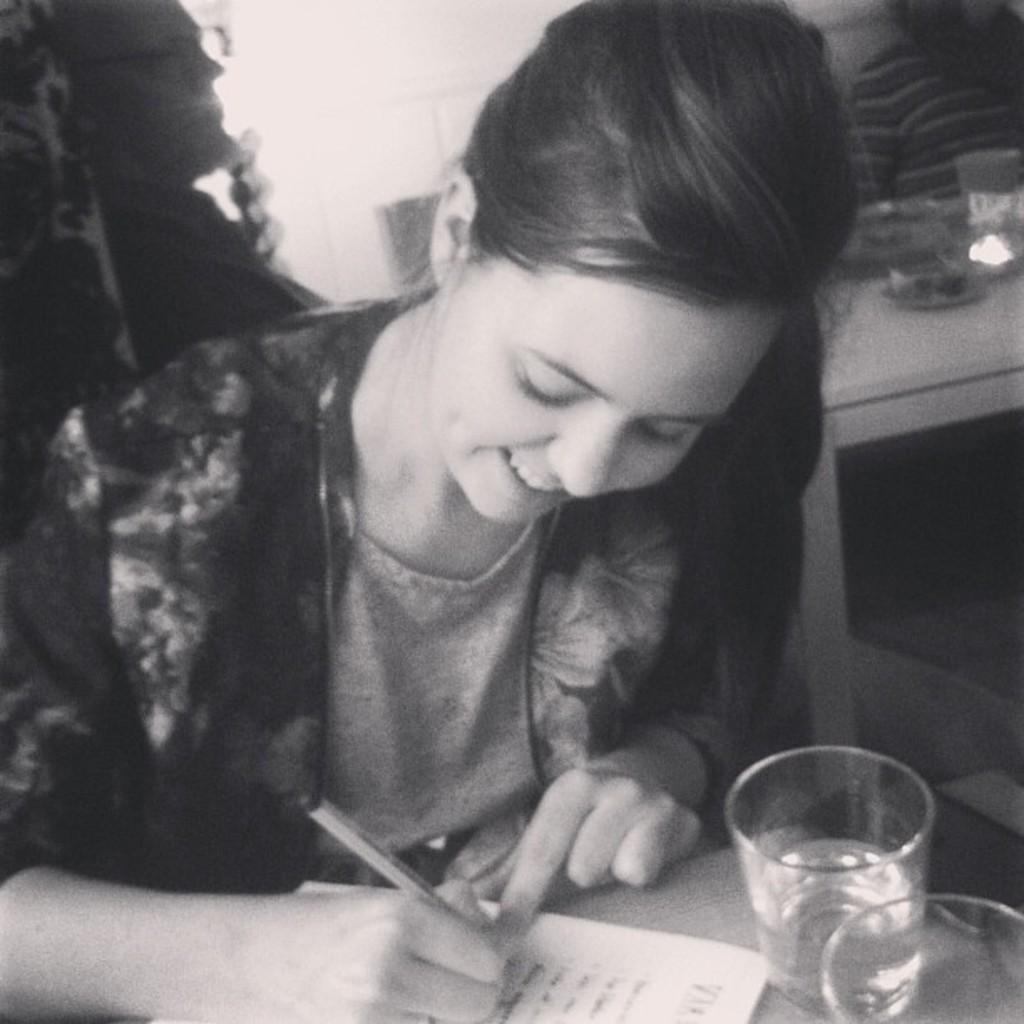How would you summarize this image in a sentence or two? This is a black and white image. Here we can see a woman sitting and writing something on a paper which is on the table with a pen and we can also see glasses and a mobile on the table. In the background there are two persons at the table and on the table there is a glass and some other objects and a wall. 